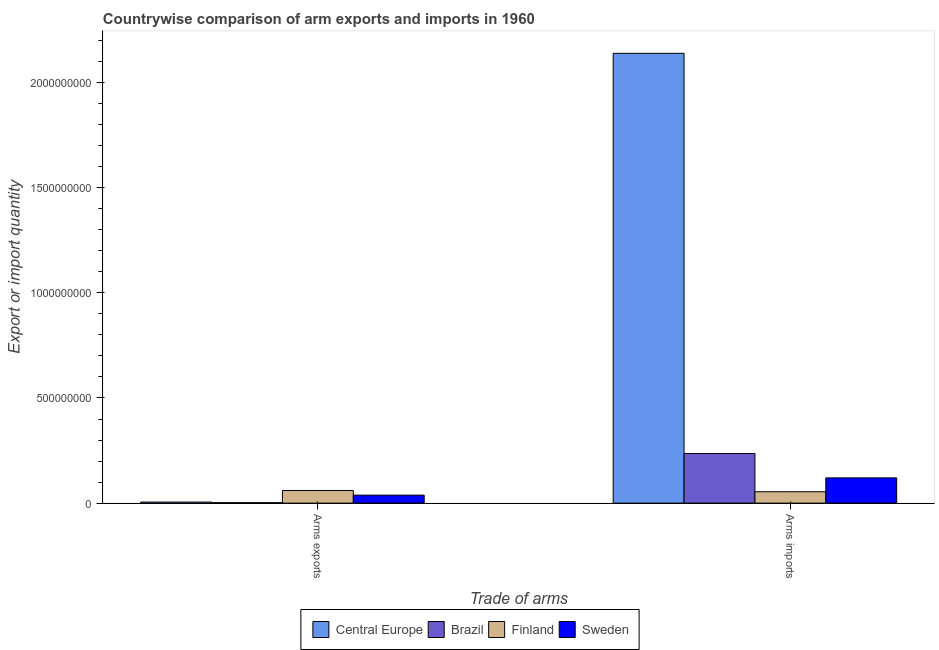How many different coloured bars are there?
Offer a terse response. 4. How many groups of bars are there?
Provide a succinct answer. 2. Are the number of bars per tick equal to the number of legend labels?
Your response must be concise. Yes. Are the number of bars on each tick of the X-axis equal?
Offer a very short reply. Yes. What is the label of the 2nd group of bars from the left?
Offer a terse response. Arms imports. What is the arms exports in Central Europe?
Your answer should be very brief. 5.00e+06. Across all countries, what is the maximum arms imports?
Keep it short and to the point. 2.14e+09. Across all countries, what is the minimum arms exports?
Your answer should be very brief. 2.00e+06. In which country was the arms imports maximum?
Ensure brevity in your answer.  Central Europe. What is the total arms exports in the graph?
Offer a terse response. 1.05e+08. What is the difference between the arms exports in Central Europe and that in Brazil?
Ensure brevity in your answer.  3.00e+06. What is the difference between the arms imports in Brazil and the arms exports in Finland?
Offer a terse response. 1.76e+08. What is the average arms imports per country?
Offer a very short reply. 6.37e+08. What is the difference between the arms exports and arms imports in Finland?
Provide a succinct answer. 6.00e+06. In how many countries, is the arms imports greater than 200000000 ?
Your response must be concise. 2. What is the ratio of the arms imports in Brazil to that in Central Europe?
Your answer should be very brief. 0.11. Is the arms exports in Sweden less than that in Finland?
Give a very brief answer. Yes. What does the 2nd bar from the right in Arms imports represents?
Ensure brevity in your answer.  Finland. How many bars are there?
Ensure brevity in your answer.  8. Are the values on the major ticks of Y-axis written in scientific E-notation?
Your answer should be very brief. No. Does the graph contain any zero values?
Keep it short and to the point. No. Does the graph contain grids?
Your answer should be compact. No. Where does the legend appear in the graph?
Your answer should be compact. Bottom center. What is the title of the graph?
Your response must be concise. Countrywise comparison of arm exports and imports in 1960. Does "Finland" appear as one of the legend labels in the graph?
Offer a very short reply. Yes. What is the label or title of the X-axis?
Make the answer very short. Trade of arms. What is the label or title of the Y-axis?
Your response must be concise. Export or import quantity. What is the Export or import quantity in Central Europe in Arms exports?
Give a very brief answer. 5.00e+06. What is the Export or import quantity of Brazil in Arms exports?
Provide a succinct answer. 2.00e+06. What is the Export or import quantity in Finland in Arms exports?
Offer a terse response. 6.00e+07. What is the Export or import quantity in Sweden in Arms exports?
Your answer should be very brief. 3.80e+07. What is the Export or import quantity in Central Europe in Arms imports?
Offer a terse response. 2.14e+09. What is the Export or import quantity of Brazil in Arms imports?
Your answer should be compact. 2.36e+08. What is the Export or import quantity in Finland in Arms imports?
Your response must be concise. 5.40e+07. What is the Export or import quantity in Sweden in Arms imports?
Provide a short and direct response. 1.20e+08. Across all Trade of arms, what is the maximum Export or import quantity of Central Europe?
Your response must be concise. 2.14e+09. Across all Trade of arms, what is the maximum Export or import quantity in Brazil?
Provide a short and direct response. 2.36e+08. Across all Trade of arms, what is the maximum Export or import quantity in Finland?
Your answer should be very brief. 6.00e+07. Across all Trade of arms, what is the maximum Export or import quantity of Sweden?
Make the answer very short. 1.20e+08. Across all Trade of arms, what is the minimum Export or import quantity of Central Europe?
Your answer should be very brief. 5.00e+06. Across all Trade of arms, what is the minimum Export or import quantity of Finland?
Make the answer very short. 5.40e+07. Across all Trade of arms, what is the minimum Export or import quantity of Sweden?
Keep it short and to the point. 3.80e+07. What is the total Export or import quantity of Central Europe in the graph?
Provide a succinct answer. 2.14e+09. What is the total Export or import quantity of Brazil in the graph?
Provide a succinct answer. 2.38e+08. What is the total Export or import quantity of Finland in the graph?
Your response must be concise. 1.14e+08. What is the total Export or import quantity in Sweden in the graph?
Your answer should be compact. 1.58e+08. What is the difference between the Export or import quantity of Central Europe in Arms exports and that in Arms imports?
Your answer should be very brief. -2.13e+09. What is the difference between the Export or import quantity in Brazil in Arms exports and that in Arms imports?
Offer a terse response. -2.34e+08. What is the difference between the Export or import quantity of Sweden in Arms exports and that in Arms imports?
Provide a succinct answer. -8.20e+07. What is the difference between the Export or import quantity of Central Europe in Arms exports and the Export or import quantity of Brazil in Arms imports?
Your response must be concise. -2.31e+08. What is the difference between the Export or import quantity of Central Europe in Arms exports and the Export or import quantity of Finland in Arms imports?
Your answer should be compact. -4.90e+07. What is the difference between the Export or import quantity of Central Europe in Arms exports and the Export or import quantity of Sweden in Arms imports?
Give a very brief answer. -1.15e+08. What is the difference between the Export or import quantity in Brazil in Arms exports and the Export or import quantity in Finland in Arms imports?
Your response must be concise. -5.20e+07. What is the difference between the Export or import quantity in Brazil in Arms exports and the Export or import quantity in Sweden in Arms imports?
Make the answer very short. -1.18e+08. What is the difference between the Export or import quantity of Finland in Arms exports and the Export or import quantity of Sweden in Arms imports?
Provide a succinct answer. -6.00e+07. What is the average Export or import quantity in Central Europe per Trade of arms?
Your response must be concise. 1.07e+09. What is the average Export or import quantity in Brazil per Trade of arms?
Give a very brief answer. 1.19e+08. What is the average Export or import quantity of Finland per Trade of arms?
Give a very brief answer. 5.70e+07. What is the average Export or import quantity in Sweden per Trade of arms?
Give a very brief answer. 7.90e+07. What is the difference between the Export or import quantity of Central Europe and Export or import quantity of Brazil in Arms exports?
Your response must be concise. 3.00e+06. What is the difference between the Export or import quantity in Central Europe and Export or import quantity in Finland in Arms exports?
Offer a terse response. -5.50e+07. What is the difference between the Export or import quantity in Central Europe and Export or import quantity in Sweden in Arms exports?
Your response must be concise. -3.30e+07. What is the difference between the Export or import quantity in Brazil and Export or import quantity in Finland in Arms exports?
Keep it short and to the point. -5.80e+07. What is the difference between the Export or import quantity in Brazil and Export or import quantity in Sweden in Arms exports?
Keep it short and to the point. -3.60e+07. What is the difference between the Export or import quantity in Finland and Export or import quantity in Sweden in Arms exports?
Give a very brief answer. 2.20e+07. What is the difference between the Export or import quantity in Central Europe and Export or import quantity in Brazil in Arms imports?
Your answer should be very brief. 1.90e+09. What is the difference between the Export or import quantity of Central Europe and Export or import quantity of Finland in Arms imports?
Offer a terse response. 2.08e+09. What is the difference between the Export or import quantity of Central Europe and Export or import quantity of Sweden in Arms imports?
Provide a short and direct response. 2.02e+09. What is the difference between the Export or import quantity in Brazil and Export or import quantity in Finland in Arms imports?
Offer a terse response. 1.82e+08. What is the difference between the Export or import quantity in Brazil and Export or import quantity in Sweden in Arms imports?
Your answer should be compact. 1.16e+08. What is the difference between the Export or import quantity of Finland and Export or import quantity of Sweden in Arms imports?
Keep it short and to the point. -6.60e+07. What is the ratio of the Export or import quantity of Central Europe in Arms exports to that in Arms imports?
Offer a terse response. 0. What is the ratio of the Export or import quantity of Brazil in Arms exports to that in Arms imports?
Your answer should be compact. 0.01. What is the ratio of the Export or import quantity of Sweden in Arms exports to that in Arms imports?
Give a very brief answer. 0.32. What is the difference between the highest and the second highest Export or import quantity of Central Europe?
Your answer should be very brief. 2.13e+09. What is the difference between the highest and the second highest Export or import quantity in Brazil?
Provide a short and direct response. 2.34e+08. What is the difference between the highest and the second highest Export or import quantity of Finland?
Give a very brief answer. 6.00e+06. What is the difference between the highest and the second highest Export or import quantity in Sweden?
Give a very brief answer. 8.20e+07. What is the difference between the highest and the lowest Export or import quantity of Central Europe?
Your response must be concise. 2.13e+09. What is the difference between the highest and the lowest Export or import quantity in Brazil?
Provide a succinct answer. 2.34e+08. What is the difference between the highest and the lowest Export or import quantity of Sweden?
Give a very brief answer. 8.20e+07. 